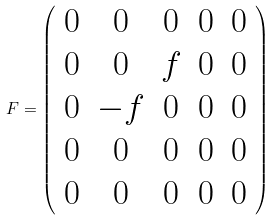Convert formula to latex. <formula><loc_0><loc_0><loc_500><loc_500>F = \left ( \begin{array} { c c c c c } { 0 } & { 0 } & { 0 } & { 0 } & { 0 } \\ { 0 } & { 0 } & { f } & { 0 } & { 0 } \\ { 0 } & { - f } & { 0 } & { 0 } & { 0 } \\ { 0 } & { 0 } & { 0 } & { 0 } & { 0 } \\ { 0 } & { 0 } & { 0 } & { 0 } & { 0 } \end{array} \right )</formula> 